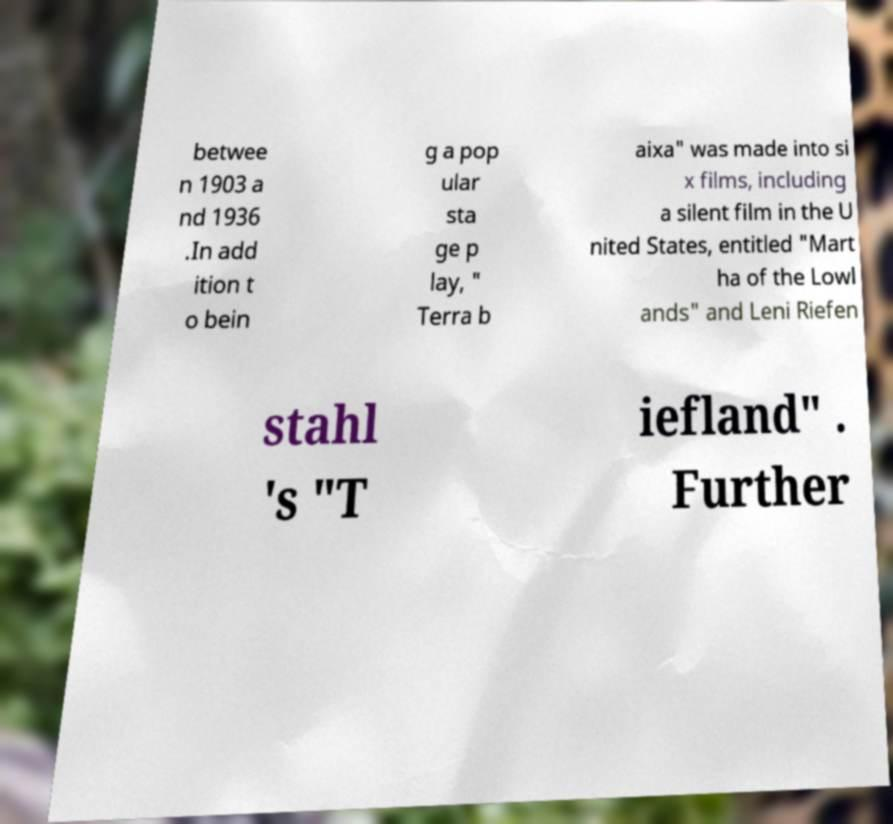Please identify and transcribe the text found in this image. betwee n 1903 a nd 1936 .In add ition t o bein g a pop ular sta ge p lay, " Terra b aixa" was made into si x films, including a silent film in the U nited States, entitled "Mart ha of the Lowl ands" and Leni Riefen stahl 's "T iefland" . Further 